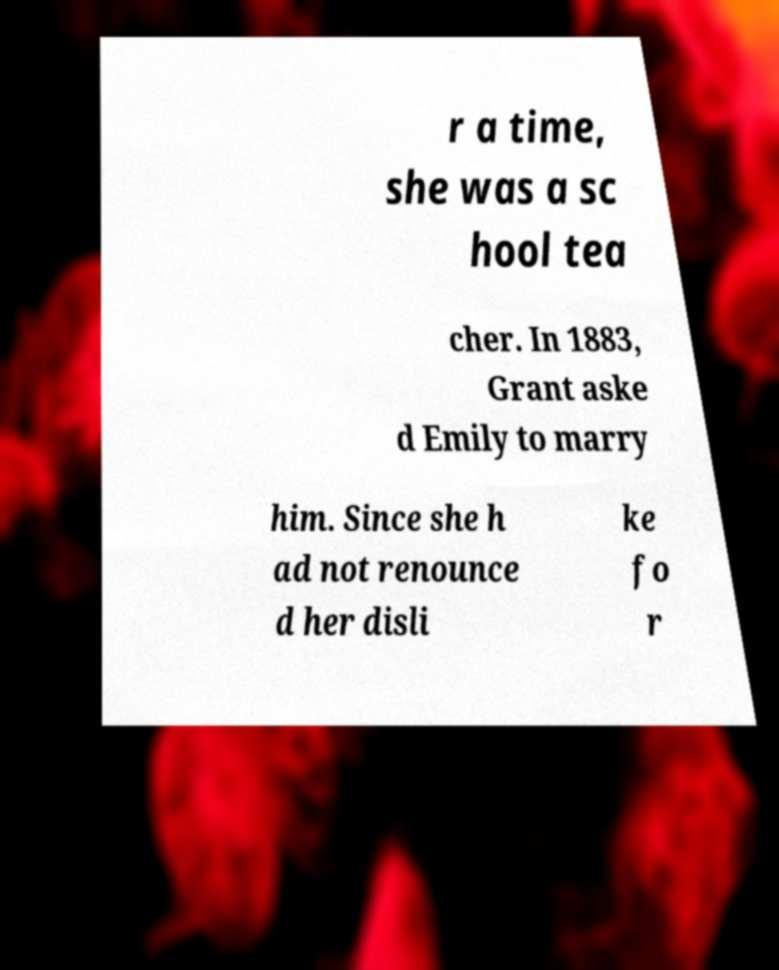What messages or text are displayed in this image? I need them in a readable, typed format. r a time, she was a sc hool tea cher. In 1883, Grant aske d Emily to marry him. Since she h ad not renounce d her disli ke fo r 